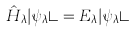Convert formula to latex. <formula><loc_0><loc_0><loc_500><loc_500>\hat { H } _ { \lambda } | \psi _ { \lambda } \rangle = E _ { \lambda } | \psi _ { \lambda } \rangle</formula> 